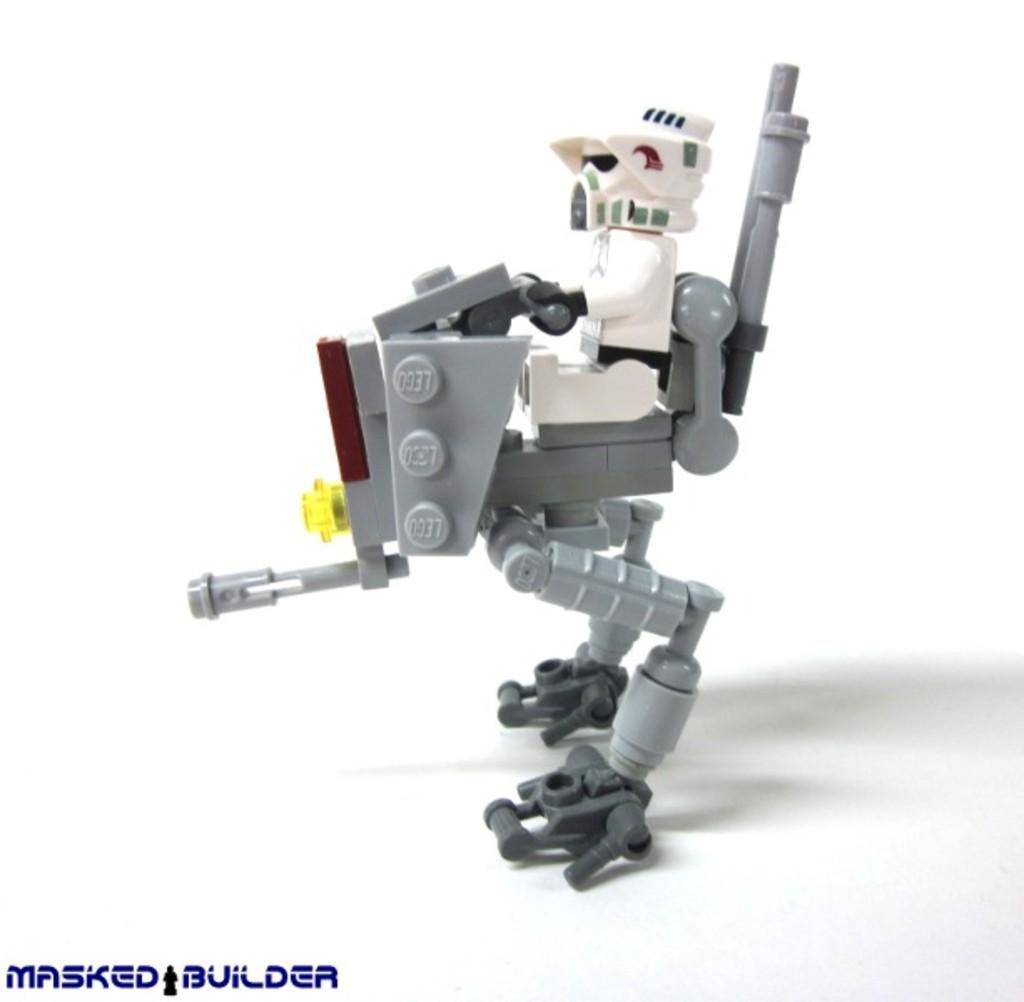How would you summarize this image in a sentence or two? In this image we can see a toy. There is some text written at the bottom of the image. 